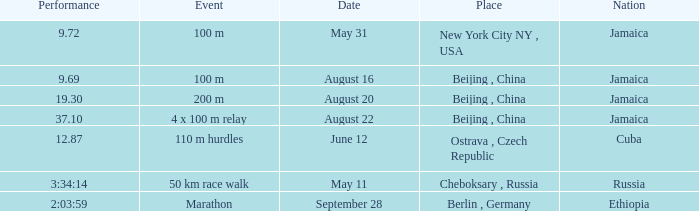Which nation ran a time of 9.69 seconds? Jamaica. 